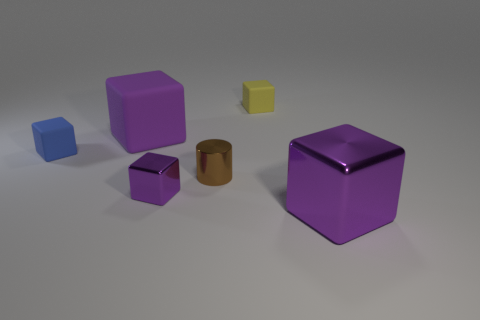Do the small yellow thing and the small brown metallic object have the same shape?
Your response must be concise. No. Are there any other things that are the same color as the large matte block?
Ensure brevity in your answer.  Yes. There is a small yellow matte thing; is it the same shape as the large thing in front of the tiny blue block?
Offer a terse response. Yes. There is a small cube that is to the left of the purple metal block behind the large purple cube to the right of the small brown cylinder; what is its color?
Ensure brevity in your answer.  Blue. There is a rubber object to the right of the large purple rubber object; does it have the same shape as the tiny purple metallic object?
Your answer should be very brief. Yes. What is the small blue block made of?
Your response must be concise. Rubber. What is the shape of the thing that is in front of the purple metallic block that is to the left of the large thing that is in front of the big purple matte thing?
Your answer should be very brief. Cube. What number of other objects are the same shape as the small purple metallic thing?
Offer a terse response. 4. There is a small metallic cube; is its color the same as the big object left of the tiny yellow cube?
Your answer should be compact. Yes. How many large yellow shiny cylinders are there?
Offer a terse response. 0. 